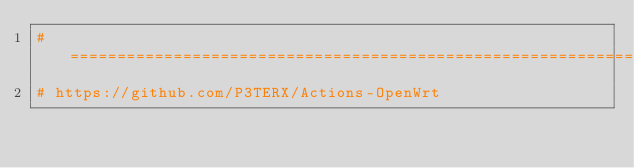Convert code to text. <code><loc_0><loc_0><loc_500><loc_500><_Bash_>#============================================================
# https://github.com/P3TERX/Actions-OpenWrt</code> 